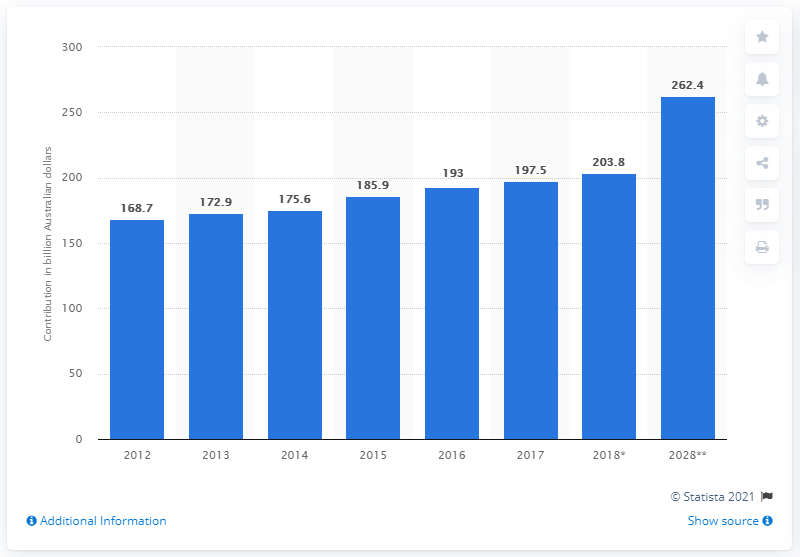Outline some significant characteristics in this image. In 2028, the travel and tourism industry contributed X% to the gross domestic product of Australia, where X is a number greater than 262.4. 